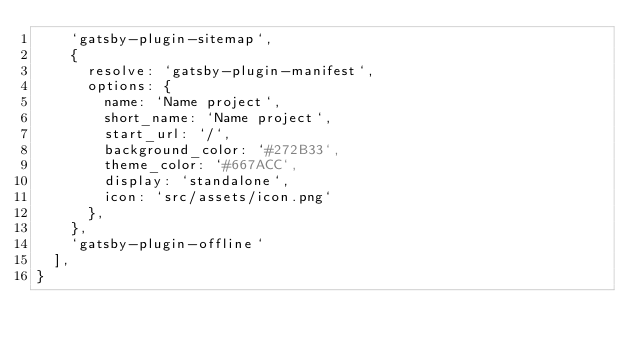Convert code to text. <code><loc_0><loc_0><loc_500><loc_500><_JavaScript_>    `gatsby-plugin-sitemap`,
    {
      resolve: `gatsby-plugin-manifest`,
      options: {
        name: `Name project`,
        short_name: `Name project`,
        start_url: `/`,
        background_color: `#272B33`,
        theme_color: `#667ACC`,
        display: `standalone`,
        icon: `src/assets/icon.png`
      },
    },
    `gatsby-plugin-offline`
  ],
}
</code> 